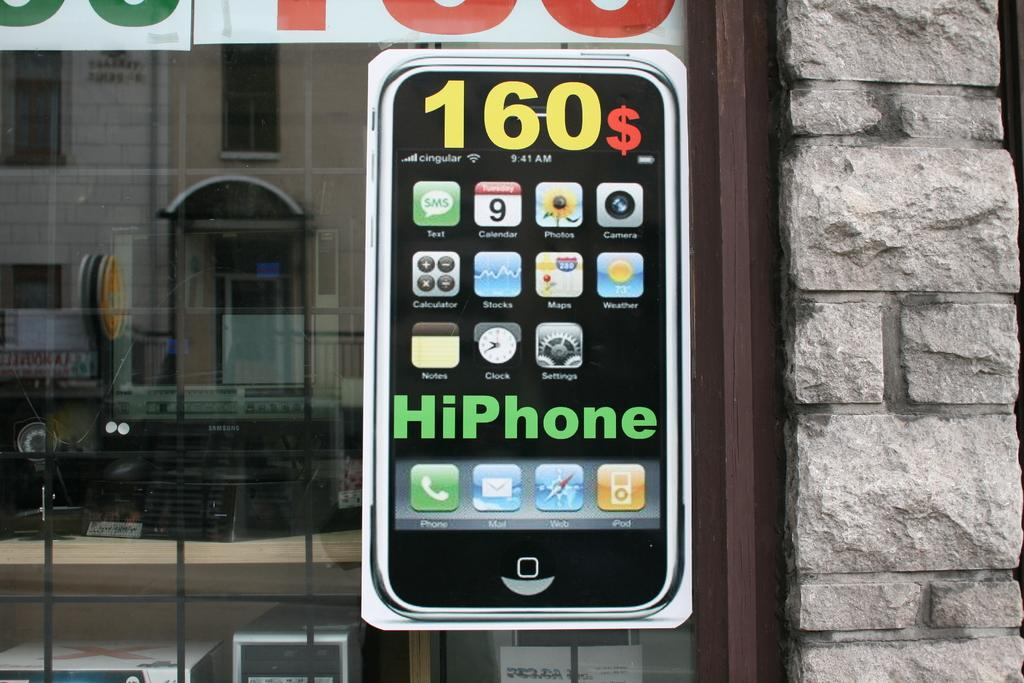<image>
Offer a succinct explanation of the picture presented. An advertisement that looks like a smart phone with 160$ on the display. 